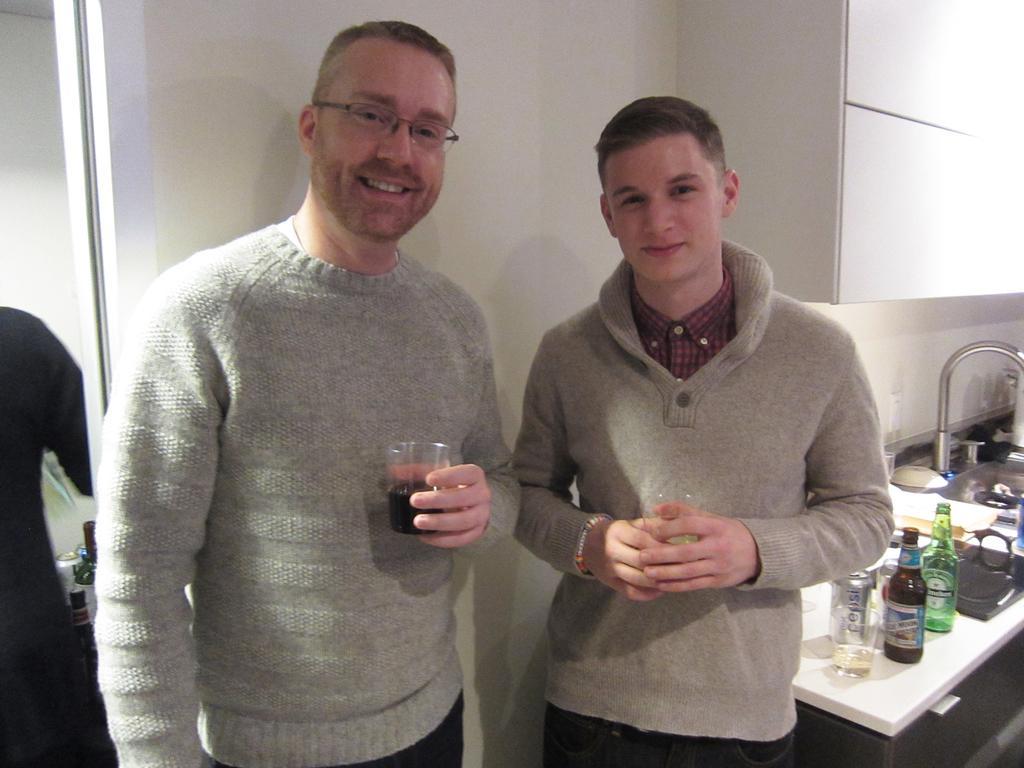Please provide a concise description of this image. In the foreground of the picture there are two persons standing. On the right there are bottles, jar, glasses, plates, tap, sink and other objects.. On the left there is a person and an object. 